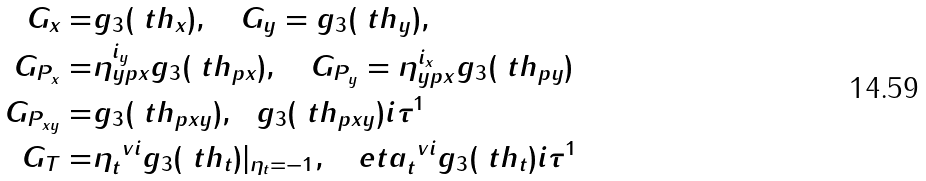Convert formula to latex. <formula><loc_0><loc_0><loc_500><loc_500>G _ { x } = & g _ { 3 } ( \ t h _ { x } ) , \quad G _ { y } = g _ { 3 } ( \ t h _ { y } ) , \\ G _ { P _ { x } } = & \eta _ { y p x } ^ { i _ { y } } g _ { 3 } ( \ t h _ { p x } ) , \quad G _ { P _ { y } } = \eta _ { y p x } ^ { i _ { x } } g _ { 3 } ( \ t h _ { p y } ) \\ G _ { P _ { x y } } = & g _ { 3 } ( \ t h _ { p x y } ) , \ \ g _ { 3 } ( \ t h _ { p x y } ) i \tau ^ { 1 } \\ G _ { T } = & \eta _ { t } ^ { \ v i } g _ { 3 } ( \ t h _ { t } ) | _ { \eta _ { t } = - 1 } , \ \ \ e t a _ { t } ^ { \ v i } g _ { 3 } ( \ t h _ { t } ) i \tau ^ { 1 }</formula> 